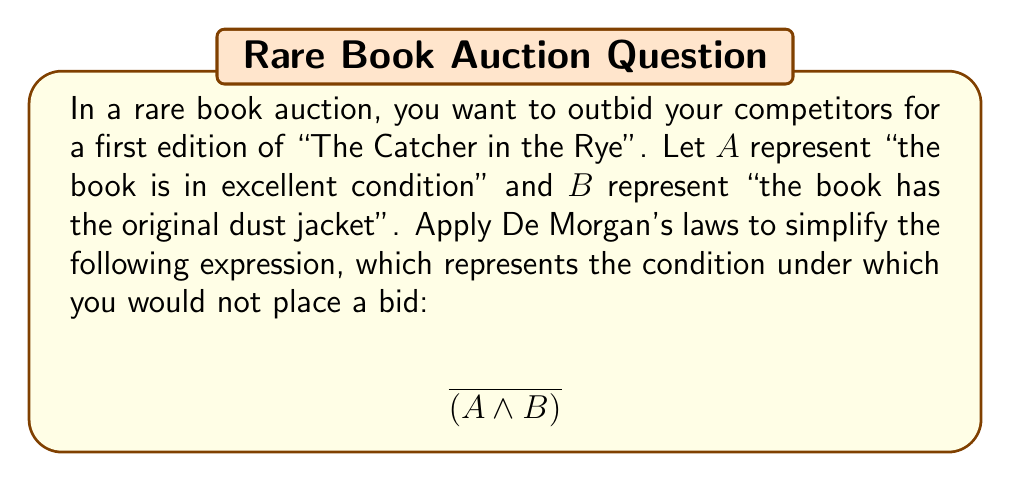Solve this math problem. To simplify this expression using De Morgan's laws, we follow these steps:

1) De Morgan's law states that the negation of a conjunction is equivalent to the disjunction of the negations. In other words:

   $\overline{(X \land Y)} \equiv \overline{X} \lor \overline{Y}$

2) Applying this to our expression:

   $\overline{(A \land B)} \equiv \overline{A} \lor \overline{B}$

3) Interpreting this result:
   - $\overline{A}$ means "the book is not in excellent condition"
   - $\overline{B}$ means "the book does not have the original dust jacket"

4) Therefore, the simplified expression $\overline{A} \lor \overline{B}$ means you would not place a bid if either the book is not in excellent condition OR it does not have the original dust jacket (or both).

This simplification allows for a clearer understanding of the bidding strategy, which could be useful for a rival collector using underhanded tactics to acquire rare books.
Answer: $\overline{A} \lor \overline{B}$ 